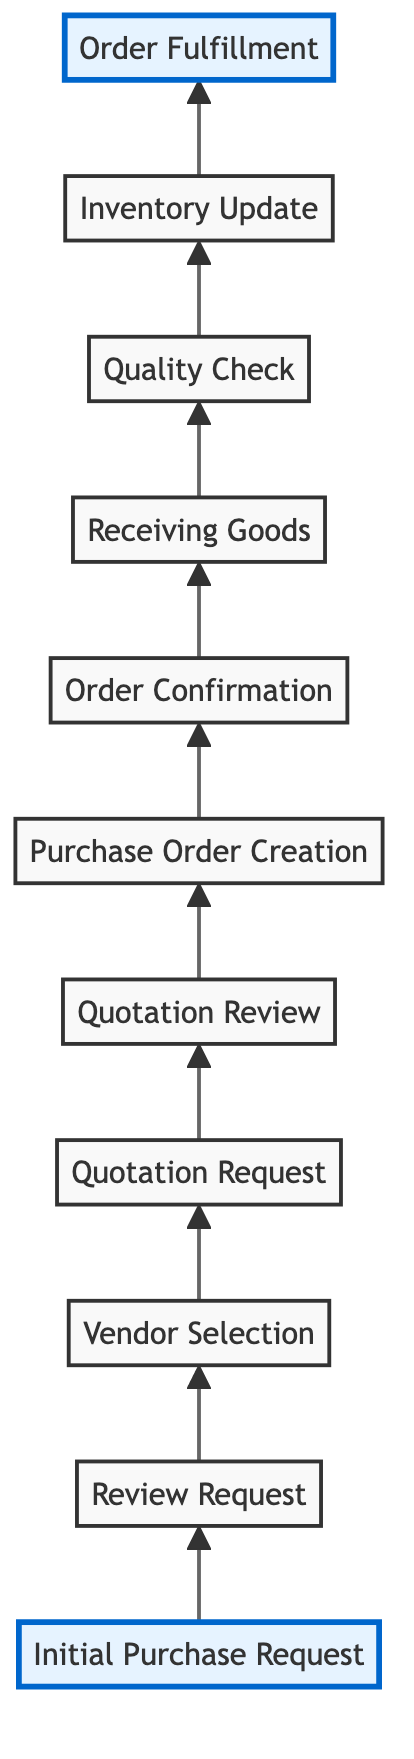What is the first step in the purchase order workflow? The first step in the workflow is "Initial Purchase Request," where store managers submit their requests for home goods.
Answer: Initial Purchase Request How many steps are in the purchase order workflow? There are a total of eleven steps in the workflow, as indicated by the eleven nodes in the diagram.
Answer: 11 What step comes after "Vendor Selection"? After "Vendor Selection," the next step is "Quotation Request," which involves requesting quotations from selected vendors.
Answer: Quotation Request Which step involves reviewing received quotations? The step that involves reviewing received quotations is "Quotation Review." This is where procurement officers analyze and compare the quotations from vendors.
Answer: Quotation Review What is the last step in the purchase order workflow? The last step in the workflow is "Order Fulfillment," where the goods are distributed to the requesting stores after all prior steps are completed.
Answer: Order Fulfillment What action follows "Receiving Goods"? The action that follows "Receiving Goods" is "Quality Check," during which the goods are inspected for quality assurance before updating the inventory.
Answer: Quality Check What term describes the step before "Purchase Order Creation"? The step before "Purchase Order Creation" is "Quotation Review"; it is essential to review quotes before creating an order.
Answer: Quotation Review In what step does the vendor confirm the order? The vendor confirms the order in the step called "Order Confirmation," where they acknowledge acceptance of the purchase order.
Answer: Order Confirmation How does the workflow progress from "Inventory Update"? The workflow progresses from "Inventory Update" to "Order Fulfillment," indicating that goods must be recorded in inventory before being distributed.
Answer: Order Fulfillment What is the primary role in "Review Request"? The primary role in "Review Request" is performed by the "Procurement Officer," who assesses the submitted purchase requests from store managers.
Answer: Procurement Officer 